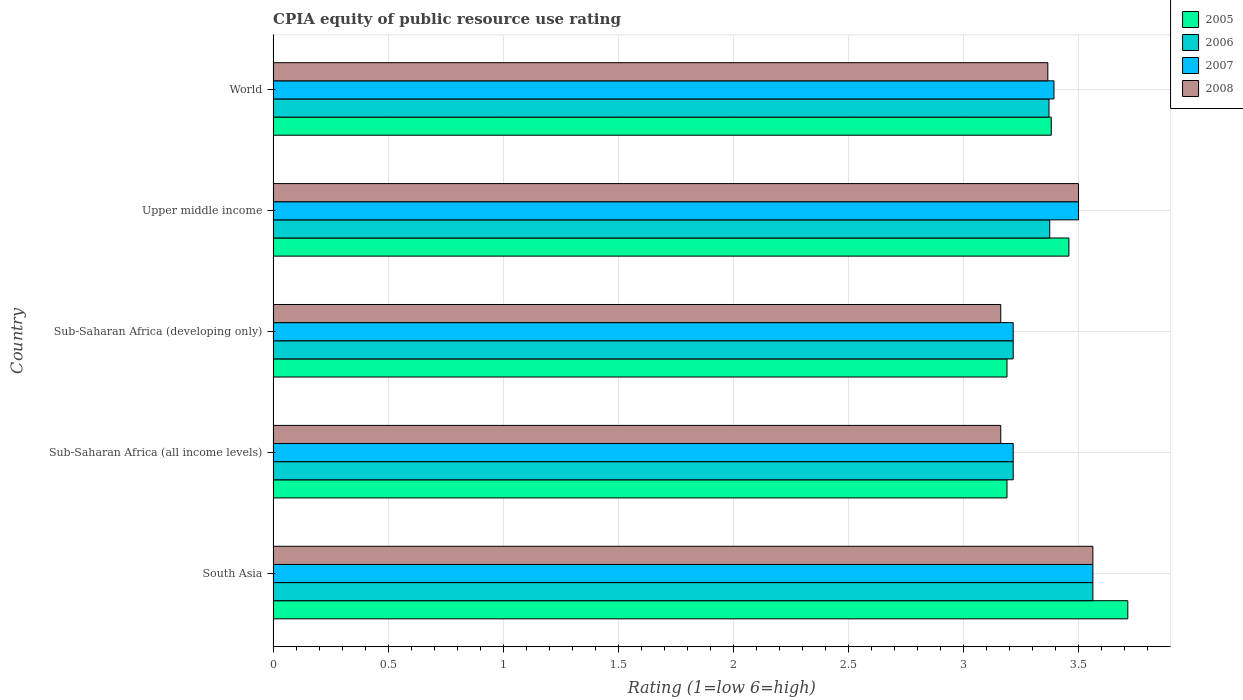How many different coloured bars are there?
Provide a succinct answer. 4. Are the number of bars per tick equal to the number of legend labels?
Keep it short and to the point. Yes. Are the number of bars on each tick of the Y-axis equal?
Make the answer very short. Yes. How many bars are there on the 1st tick from the top?
Offer a terse response. 4. What is the label of the 2nd group of bars from the top?
Make the answer very short. Upper middle income. In how many cases, is the number of bars for a given country not equal to the number of legend labels?
Provide a short and direct response. 0. What is the CPIA rating in 2005 in Upper middle income?
Keep it short and to the point. 3.46. Across all countries, what is the maximum CPIA rating in 2006?
Provide a short and direct response. 3.56. Across all countries, what is the minimum CPIA rating in 2005?
Keep it short and to the point. 3.19. In which country was the CPIA rating in 2006 maximum?
Your answer should be very brief. South Asia. In which country was the CPIA rating in 2007 minimum?
Provide a succinct answer. Sub-Saharan Africa (all income levels). What is the total CPIA rating in 2007 in the graph?
Offer a very short reply. 16.89. What is the difference between the CPIA rating in 2005 in South Asia and that in Sub-Saharan Africa (developing only)?
Your response must be concise. 0.53. What is the difference between the CPIA rating in 2008 in Sub-Saharan Africa (all income levels) and the CPIA rating in 2006 in Sub-Saharan Africa (developing only)?
Offer a terse response. -0.05. What is the average CPIA rating in 2006 per country?
Your answer should be compact. 3.35. What is the difference between the CPIA rating in 2005 and CPIA rating in 2006 in South Asia?
Offer a very short reply. 0.15. What is the ratio of the CPIA rating in 2006 in Sub-Saharan Africa (all income levels) to that in Upper middle income?
Offer a terse response. 0.95. Is the CPIA rating in 2008 in South Asia less than that in Sub-Saharan Africa (all income levels)?
Provide a succinct answer. No. What is the difference between the highest and the second highest CPIA rating in 2005?
Keep it short and to the point. 0.26. What is the difference between the highest and the lowest CPIA rating in 2005?
Your response must be concise. 0.53. In how many countries, is the CPIA rating in 2008 greater than the average CPIA rating in 2008 taken over all countries?
Your answer should be very brief. 3. Is it the case that in every country, the sum of the CPIA rating in 2005 and CPIA rating in 2007 is greater than the sum of CPIA rating in 2008 and CPIA rating in 2006?
Your response must be concise. No. Is it the case that in every country, the sum of the CPIA rating in 2006 and CPIA rating in 2008 is greater than the CPIA rating in 2005?
Your response must be concise. Yes. How many countries are there in the graph?
Give a very brief answer. 5. Does the graph contain grids?
Your answer should be compact. Yes. Where does the legend appear in the graph?
Provide a succinct answer. Top right. What is the title of the graph?
Offer a very short reply. CPIA equity of public resource use rating. What is the Rating (1=low 6=high) of 2005 in South Asia?
Your response must be concise. 3.71. What is the Rating (1=low 6=high) in 2006 in South Asia?
Your response must be concise. 3.56. What is the Rating (1=low 6=high) in 2007 in South Asia?
Give a very brief answer. 3.56. What is the Rating (1=low 6=high) in 2008 in South Asia?
Your response must be concise. 3.56. What is the Rating (1=low 6=high) of 2005 in Sub-Saharan Africa (all income levels)?
Ensure brevity in your answer.  3.19. What is the Rating (1=low 6=high) of 2006 in Sub-Saharan Africa (all income levels)?
Provide a short and direct response. 3.22. What is the Rating (1=low 6=high) of 2007 in Sub-Saharan Africa (all income levels)?
Your answer should be very brief. 3.22. What is the Rating (1=low 6=high) in 2008 in Sub-Saharan Africa (all income levels)?
Provide a short and direct response. 3.16. What is the Rating (1=low 6=high) in 2005 in Sub-Saharan Africa (developing only)?
Your answer should be very brief. 3.19. What is the Rating (1=low 6=high) in 2006 in Sub-Saharan Africa (developing only)?
Keep it short and to the point. 3.22. What is the Rating (1=low 6=high) in 2007 in Sub-Saharan Africa (developing only)?
Ensure brevity in your answer.  3.22. What is the Rating (1=low 6=high) of 2008 in Sub-Saharan Africa (developing only)?
Your answer should be very brief. 3.16. What is the Rating (1=low 6=high) of 2005 in Upper middle income?
Ensure brevity in your answer.  3.46. What is the Rating (1=low 6=high) of 2006 in Upper middle income?
Offer a very short reply. 3.38. What is the Rating (1=low 6=high) in 2007 in Upper middle income?
Your answer should be very brief. 3.5. What is the Rating (1=low 6=high) of 2008 in Upper middle income?
Your answer should be compact. 3.5. What is the Rating (1=low 6=high) in 2005 in World?
Offer a very short reply. 3.38. What is the Rating (1=low 6=high) in 2006 in World?
Give a very brief answer. 3.37. What is the Rating (1=low 6=high) in 2007 in World?
Keep it short and to the point. 3.39. What is the Rating (1=low 6=high) in 2008 in World?
Ensure brevity in your answer.  3.37. Across all countries, what is the maximum Rating (1=low 6=high) of 2005?
Make the answer very short. 3.71. Across all countries, what is the maximum Rating (1=low 6=high) of 2006?
Offer a very short reply. 3.56. Across all countries, what is the maximum Rating (1=low 6=high) of 2007?
Keep it short and to the point. 3.56. Across all countries, what is the maximum Rating (1=low 6=high) in 2008?
Provide a short and direct response. 3.56. Across all countries, what is the minimum Rating (1=low 6=high) of 2005?
Make the answer very short. 3.19. Across all countries, what is the minimum Rating (1=low 6=high) of 2006?
Provide a succinct answer. 3.22. Across all countries, what is the minimum Rating (1=low 6=high) in 2007?
Ensure brevity in your answer.  3.22. Across all countries, what is the minimum Rating (1=low 6=high) in 2008?
Make the answer very short. 3.16. What is the total Rating (1=low 6=high) of 2005 in the graph?
Your response must be concise. 16.93. What is the total Rating (1=low 6=high) of 2006 in the graph?
Keep it short and to the point. 16.74. What is the total Rating (1=low 6=high) in 2007 in the graph?
Provide a succinct answer. 16.89. What is the total Rating (1=low 6=high) in 2008 in the graph?
Provide a succinct answer. 16.75. What is the difference between the Rating (1=low 6=high) in 2005 in South Asia and that in Sub-Saharan Africa (all income levels)?
Offer a very short reply. 0.53. What is the difference between the Rating (1=low 6=high) in 2006 in South Asia and that in Sub-Saharan Africa (all income levels)?
Provide a succinct answer. 0.35. What is the difference between the Rating (1=low 6=high) in 2007 in South Asia and that in Sub-Saharan Africa (all income levels)?
Your answer should be compact. 0.35. What is the difference between the Rating (1=low 6=high) of 2008 in South Asia and that in Sub-Saharan Africa (all income levels)?
Provide a short and direct response. 0.4. What is the difference between the Rating (1=low 6=high) of 2005 in South Asia and that in Sub-Saharan Africa (developing only)?
Give a very brief answer. 0.53. What is the difference between the Rating (1=low 6=high) in 2006 in South Asia and that in Sub-Saharan Africa (developing only)?
Offer a very short reply. 0.35. What is the difference between the Rating (1=low 6=high) of 2007 in South Asia and that in Sub-Saharan Africa (developing only)?
Keep it short and to the point. 0.35. What is the difference between the Rating (1=low 6=high) of 2008 in South Asia and that in Sub-Saharan Africa (developing only)?
Provide a short and direct response. 0.4. What is the difference between the Rating (1=low 6=high) of 2005 in South Asia and that in Upper middle income?
Provide a succinct answer. 0.26. What is the difference between the Rating (1=low 6=high) of 2006 in South Asia and that in Upper middle income?
Keep it short and to the point. 0.19. What is the difference between the Rating (1=low 6=high) of 2007 in South Asia and that in Upper middle income?
Provide a succinct answer. 0.06. What is the difference between the Rating (1=low 6=high) in 2008 in South Asia and that in Upper middle income?
Give a very brief answer. 0.06. What is the difference between the Rating (1=low 6=high) in 2005 in South Asia and that in World?
Provide a succinct answer. 0.33. What is the difference between the Rating (1=low 6=high) of 2006 in South Asia and that in World?
Ensure brevity in your answer.  0.19. What is the difference between the Rating (1=low 6=high) of 2007 in South Asia and that in World?
Give a very brief answer. 0.17. What is the difference between the Rating (1=low 6=high) of 2008 in South Asia and that in World?
Your answer should be compact. 0.2. What is the difference between the Rating (1=low 6=high) in 2008 in Sub-Saharan Africa (all income levels) and that in Sub-Saharan Africa (developing only)?
Provide a succinct answer. 0. What is the difference between the Rating (1=low 6=high) of 2005 in Sub-Saharan Africa (all income levels) and that in Upper middle income?
Your answer should be very brief. -0.27. What is the difference between the Rating (1=low 6=high) in 2006 in Sub-Saharan Africa (all income levels) and that in Upper middle income?
Keep it short and to the point. -0.16. What is the difference between the Rating (1=low 6=high) of 2007 in Sub-Saharan Africa (all income levels) and that in Upper middle income?
Your answer should be very brief. -0.28. What is the difference between the Rating (1=low 6=high) of 2008 in Sub-Saharan Africa (all income levels) and that in Upper middle income?
Your answer should be compact. -0.34. What is the difference between the Rating (1=low 6=high) of 2005 in Sub-Saharan Africa (all income levels) and that in World?
Provide a short and direct response. -0.19. What is the difference between the Rating (1=low 6=high) in 2006 in Sub-Saharan Africa (all income levels) and that in World?
Offer a terse response. -0.16. What is the difference between the Rating (1=low 6=high) of 2007 in Sub-Saharan Africa (all income levels) and that in World?
Offer a terse response. -0.18. What is the difference between the Rating (1=low 6=high) in 2008 in Sub-Saharan Africa (all income levels) and that in World?
Your answer should be very brief. -0.2. What is the difference between the Rating (1=low 6=high) in 2005 in Sub-Saharan Africa (developing only) and that in Upper middle income?
Provide a succinct answer. -0.27. What is the difference between the Rating (1=low 6=high) in 2006 in Sub-Saharan Africa (developing only) and that in Upper middle income?
Offer a very short reply. -0.16. What is the difference between the Rating (1=low 6=high) of 2007 in Sub-Saharan Africa (developing only) and that in Upper middle income?
Provide a succinct answer. -0.28. What is the difference between the Rating (1=low 6=high) of 2008 in Sub-Saharan Africa (developing only) and that in Upper middle income?
Provide a short and direct response. -0.34. What is the difference between the Rating (1=low 6=high) in 2005 in Sub-Saharan Africa (developing only) and that in World?
Give a very brief answer. -0.19. What is the difference between the Rating (1=low 6=high) of 2006 in Sub-Saharan Africa (developing only) and that in World?
Make the answer very short. -0.16. What is the difference between the Rating (1=low 6=high) in 2007 in Sub-Saharan Africa (developing only) and that in World?
Offer a terse response. -0.18. What is the difference between the Rating (1=low 6=high) of 2008 in Sub-Saharan Africa (developing only) and that in World?
Offer a very short reply. -0.2. What is the difference between the Rating (1=low 6=high) of 2005 in Upper middle income and that in World?
Offer a very short reply. 0.08. What is the difference between the Rating (1=low 6=high) in 2006 in Upper middle income and that in World?
Offer a terse response. 0. What is the difference between the Rating (1=low 6=high) of 2007 in Upper middle income and that in World?
Provide a succinct answer. 0.11. What is the difference between the Rating (1=low 6=high) of 2008 in Upper middle income and that in World?
Your answer should be very brief. 0.13. What is the difference between the Rating (1=low 6=high) of 2005 in South Asia and the Rating (1=low 6=high) of 2006 in Sub-Saharan Africa (all income levels)?
Make the answer very short. 0.5. What is the difference between the Rating (1=low 6=high) in 2005 in South Asia and the Rating (1=low 6=high) in 2007 in Sub-Saharan Africa (all income levels)?
Your response must be concise. 0.5. What is the difference between the Rating (1=low 6=high) in 2005 in South Asia and the Rating (1=low 6=high) in 2008 in Sub-Saharan Africa (all income levels)?
Keep it short and to the point. 0.55. What is the difference between the Rating (1=low 6=high) of 2006 in South Asia and the Rating (1=low 6=high) of 2007 in Sub-Saharan Africa (all income levels)?
Give a very brief answer. 0.35. What is the difference between the Rating (1=low 6=high) of 2006 in South Asia and the Rating (1=low 6=high) of 2008 in Sub-Saharan Africa (all income levels)?
Provide a short and direct response. 0.4. What is the difference between the Rating (1=low 6=high) in 2007 in South Asia and the Rating (1=low 6=high) in 2008 in Sub-Saharan Africa (all income levels)?
Make the answer very short. 0.4. What is the difference between the Rating (1=low 6=high) of 2005 in South Asia and the Rating (1=low 6=high) of 2006 in Sub-Saharan Africa (developing only)?
Offer a terse response. 0.5. What is the difference between the Rating (1=low 6=high) of 2005 in South Asia and the Rating (1=low 6=high) of 2007 in Sub-Saharan Africa (developing only)?
Provide a succinct answer. 0.5. What is the difference between the Rating (1=low 6=high) of 2005 in South Asia and the Rating (1=low 6=high) of 2008 in Sub-Saharan Africa (developing only)?
Your response must be concise. 0.55. What is the difference between the Rating (1=low 6=high) in 2006 in South Asia and the Rating (1=low 6=high) in 2007 in Sub-Saharan Africa (developing only)?
Your response must be concise. 0.35. What is the difference between the Rating (1=low 6=high) in 2006 in South Asia and the Rating (1=low 6=high) in 2008 in Sub-Saharan Africa (developing only)?
Ensure brevity in your answer.  0.4. What is the difference between the Rating (1=low 6=high) in 2007 in South Asia and the Rating (1=low 6=high) in 2008 in Sub-Saharan Africa (developing only)?
Provide a succinct answer. 0.4. What is the difference between the Rating (1=low 6=high) in 2005 in South Asia and the Rating (1=low 6=high) in 2006 in Upper middle income?
Offer a terse response. 0.34. What is the difference between the Rating (1=low 6=high) in 2005 in South Asia and the Rating (1=low 6=high) in 2007 in Upper middle income?
Give a very brief answer. 0.21. What is the difference between the Rating (1=low 6=high) of 2005 in South Asia and the Rating (1=low 6=high) of 2008 in Upper middle income?
Your response must be concise. 0.21. What is the difference between the Rating (1=low 6=high) of 2006 in South Asia and the Rating (1=low 6=high) of 2007 in Upper middle income?
Keep it short and to the point. 0.06. What is the difference between the Rating (1=low 6=high) in 2006 in South Asia and the Rating (1=low 6=high) in 2008 in Upper middle income?
Offer a terse response. 0.06. What is the difference between the Rating (1=low 6=high) in 2007 in South Asia and the Rating (1=low 6=high) in 2008 in Upper middle income?
Your response must be concise. 0.06. What is the difference between the Rating (1=low 6=high) in 2005 in South Asia and the Rating (1=low 6=high) in 2006 in World?
Give a very brief answer. 0.34. What is the difference between the Rating (1=low 6=high) of 2005 in South Asia and the Rating (1=low 6=high) of 2007 in World?
Your response must be concise. 0.32. What is the difference between the Rating (1=low 6=high) of 2005 in South Asia and the Rating (1=low 6=high) of 2008 in World?
Ensure brevity in your answer.  0.35. What is the difference between the Rating (1=low 6=high) in 2006 in South Asia and the Rating (1=low 6=high) in 2007 in World?
Your answer should be compact. 0.17. What is the difference between the Rating (1=low 6=high) of 2006 in South Asia and the Rating (1=low 6=high) of 2008 in World?
Your answer should be very brief. 0.2. What is the difference between the Rating (1=low 6=high) in 2007 in South Asia and the Rating (1=low 6=high) in 2008 in World?
Keep it short and to the point. 0.2. What is the difference between the Rating (1=low 6=high) of 2005 in Sub-Saharan Africa (all income levels) and the Rating (1=low 6=high) of 2006 in Sub-Saharan Africa (developing only)?
Offer a very short reply. -0.03. What is the difference between the Rating (1=low 6=high) in 2005 in Sub-Saharan Africa (all income levels) and the Rating (1=low 6=high) in 2007 in Sub-Saharan Africa (developing only)?
Ensure brevity in your answer.  -0.03. What is the difference between the Rating (1=low 6=high) of 2005 in Sub-Saharan Africa (all income levels) and the Rating (1=low 6=high) of 2008 in Sub-Saharan Africa (developing only)?
Keep it short and to the point. 0.03. What is the difference between the Rating (1=low 6=high) in 2006 in Sub-Saharan Africa (all income levels) and the Rating (1=low 6=high) in 2007 in Sub-Saharan Africa (developing only)?
Offer a terse response. 0. What is the difference between the Rating (1=low 6=high) in 2006 in Sub-Saharan Africa (all income levels) and the Rating (1=low 6=high) in 2008 in Sub-Saharan Africa (developing only)?
Provide a short and direct response. 0.05. What is the difference between the Rating (1=low 6=high) in 2007 in Sub-Saharan Africa (all income levels) and the Rating (1=low 6=high) in 2008 in Sub-Saharan Africa (developing only)?
Offer a very short reply. 0.05. What is the difference between the Rating (1=low 6=high) of 2005 in Sub-Saharan Africa (all income levels) and the Rating (1=low 6=high) of 2006 in Upper middle income?
Your answer should be very brief. -0.19. What is the difference between the Rating (1=low 6=high) of 2005 in Sub-Saharan Africa (all income levels) and the Rating (1=low 6=high) of 2007 in Upper middle income?
Your response must be concise. -0.31. What is the difference between the Rating (1=low 6=high) of 2005 in Sub-Saharan Africa (all income levels) and the Rating (1=low 6=high) of 2008 in Upper middle income?
Ensure brevity in your answer.  -0.31. What is the difference between the Rating (1=low 6=high) in 2006 in Sub-Saharan Africa (all income levels) and the Rating (1=low 6=high) in 2007 in Upper middle income?
Offer a very short reply. -0.28. What is the difference between the Rating (1=low 6=high) in 2006 in Sub-Saharan Africa (all income levels) and the Rating (1=low 6=high) in 2008 in Upper middle income?
Keep it short and to the point. -0.28. What is the difference between the Rating (1=low 6=high) of 2007 in Sub-Saharan Africa (all income levels) and the Rating (1=low 6=high) of 2008 in Upper middle income?
Your response must be concise. -0.28. What is the difference between the Rating (1=low 6=high) of 2005 in Sub-Saharan Africa (all income levels) and the Rating (1=low 6=high) of 2006 in World?
Make the answer very short. -0.18. What is the difference between the Rating (1=low 6=high) in 2005 in Sub-Saharan Africa (all income levels) and the Rating (1=low 6=high) in 2007 in World?
Your answer should be compact. -0.2. What is the difference between the Rating (1=low 6=high) in 2005 in Sub-Saharan Africa (all income levels) and the Rating (1=low 6=high) in 2008 in World?
Provide a short and direct response. -0.18. What is the difference between the Rating (1=low 6=high) in 2006 in Sub-Saharan Africa (all income levels) and the Rating (1=low 6=high) in 2007 in World?
Offer a very short reply. -0.18. What is the difference between the Rating (1=low 6=high) in 2006 in Sub-Saharan Africa (all income levels) and the Rating (1=low 6=high) in 2008 in World?
Your answer should be very brief. -0.15. What is the difference between the Rating (1=low 6=high) of 2007 in Sub-Saharan Africa (all income levels) and the Rating (1=low 6=high) of 2008 in World?
Offer a very short reply. -0.15. What is the difference between the Rating (1=low 6=high) of 2005 in Sub-Saharan Africa (developing only) and the Rating (1=low 6=high) of 2006 in Upper middle income?
Ensure brevity in your answer.  -0.19. What is the difference between the Rating (1=low 6=high) of 2005 in Sub-Saharan Africa (developing only) and the Rating (1=low 6=high) of 2007 in Upper middle income?
Offer a terse response. -0.31. What is the difference between the Rating (1=low 6=high) in 2005 in Sub-Saharan Africa (developing only) and the Rating (1=low 6=high) in 2008 in Upper middle income?
Your answer should be very brief. -0.31. What is the difference between the Rating (1=low 6=high) in 2006 in Sub-Saharan Africa (developing only) and the Rating (1=low 6=high) in 2007 in Upper middle income?
Your answer should be compact. -0.28. What is the difference between the Rating (1=low 6=high) of 2006 in Sub-Saharan Africa (developing only) and the Rating (1=low 6=high) of 2008 in Upper middle income?
Provide a short and direct response. -0.28. What is the difference between the Rating (1=low 6=high) of 2007 in Sub-Saharan Africa (developing only) and the Rating (1=low 6=high) of 2008 in Upper middle income?
Provide a succinct answer. -0.28. What is the difference between the Rating (1=low 6=high) of 2005 in Sub-Saharan Africa (developing only) and the Rating (1=low 6=high) of 2006 in World?
Your answer should be very brief. -0.18. What is the difference between the Rating (1=low 6=high) in 2005 in Sub-Saharan Africa (developing only) and the Rating (1=low 6=high) in 2007 in World?
Give a very brief answer. -0.2. What is the difference between the Rating (1=low 6=high) in 2005 in Sub-Saharan Africa (developing only) and the Rating (1=low 6=high) in 2008 in World?
Your response must be concise. -0.18. What is the difference between the Rating (1=low 6=high) in 2006 in Sub-Saharan Africa (developing only) and the Rating (1=low 6=high) in 2007 in World?
Ensure brevity in your answer.  -0.18. What is the difference between the Rating (1=low 6=high) in 2006 in Sub-Saharan Africa (developing only) and the Rating (1=low 6=high) in 2008 in World?
Offer a terse response. -0.15. What is the difference between the Rating (1=low 6=high) of 2007 in Sub-Saharan Africa (developing only) and the Rating (1=low 6=high) of 2008 in World?
Provide a succinct answer. -0.15. What is the difference between the Rating (1=low 6=high) of 2005 in Upper middle income and the Rating (1=low 6=high) of 2006 in World?
Keep it short and to the point. 0.09. What is the difference between the Rating (1=low 6=high) in 2005 in Upper middle income and the Rating (1=low 6=high) in 2007 in World?
Your response must be concise. 0.07. What is the difference between the Rating (1=low 6=high) in 2005 in Upper middle income and the Rating (1=low 6=high) in 2008 in World?
Keep it short and to the point. 0.09. What is the difference between the Rating (1=low 6=high) in 2006 in Upper middle income and the Rating (1=low 6=high) in 2007 in World?
Provide a succinct answer. -0.02. What is the difference between the Rating (1=low 6=high) of 2006 in Upper middle income and the Rating (1=low 6=high) of 2008 in World?
Offer a terse response. 0.01. What is the difference between the Rating (1=low 6=high) in 2007 in Upper middle income and the Rating (1=low 6=high) in 2008 in World?
Ensure brevity in your answer.  0.13. What is the average Rating (1=low 6=high) in 2005 per country?
Your response must be concise. 3.39. What is the average Rating (1=low 6=high) of 2006 per country?
Make the answer very short. 3.35. What is the average Rating (1=low 6=high) in 2007 per country?
Provide a short and direct response. 3.38. What is the average Rating (1=low 6=high) of 2008 per country?
Provide a short and direct response. 3.35. What is the difference between the Rating (1=low 6=high) of 2005 and Rating (1=low 6=high) of 2006 in South Asia?
Your answer should be compact. 0.15. What is the difference between the Rating (1=low 6=high) of 2005 and Rating (1=low 6=high) of 2007 in South Asia?
Your answer should be compact. 0.15. What is the difference between the Rating (1=low 6=high) of 2005 and Rating (1=low 6=high) of 2008 in South Asia?
Your answer should be very brief. 0.15. What is the difference between the Rating (1=low 6=high) in 2006 and Rating (1=low 6=high) in 2007 in South Asia?
Provide a succinct answer. 0. What is the difference between the Rating (1=low 6=high) of 2006 and Rating (1=low 6=high) of 2008 in South Asia?
Make the answer very short. 0. What is the difference between the Rating (1=low 6=high) of 2007 and Rating (1=low 6=high) of 2008 in South Asia?
Keep it short and to the point. 0. What is the difference between the Rating (1=low 6=high) of 2005 and Rating (1=low 6=high) of 2006 in Sub-Saharan Africa (all income levels)?
Provide a succinct answer. -0.03. What is the difference between the Rating (1=low 6=high) in 2005 and Rating (1=low 6=high) in 2007 in Sub-Saharan Africa (all income levels)?
Your answer should be very brief. -0.03. What is the difference between the Rating (1=low 6=high) of 2005 and Rating (1=low 6=high) of 2008 in Sub-Saharan Africa (all income levels)?
Ensure brevity in your answer.  0.03. What is the difference between the Rating (1=low 6=high) of 2006 and Rating (1=low 6=high) of 2008 in Sub-Saharan Africa (all income levels)?
Provide a short and direct response. 0.05. What is the difference between the Rating (1=low 6=high) in 2007 and Rating (1=low 6=high) in 2008 in Sub-Saharan Africa (all income levels)?
Provide a succinct answer. 0.05. What is the difference between the Rating (1=low 6=high) in 2005 and Rating (1=low 6=high) in 2006 in Sub-Saharan Africa (developing only)?
Make the answer very short. -0.03. What is the difference between the Rating (1=low 6=high) of 2005 and Rating (1=low 6=high) of 2007 in Sub-Saharan Africa (developing only)?
Ensure brevity in your answer.  -0.03. What is the difference between the Rating (1=low 6=high) in 2005 and Rating (1=low 6=high) in 2008 in Sub-Saharan Africa (developing only)?
Your answer should be very brief. 0.03. What is the difference between the Rating (1=low 6=high) of 2006 and Rating (1=low 6=high) of 2008 in Sub-Saharan Africa (developing only)?
Your response must be concise. 0.05. What is the difference between the Rating (1=low 6=high) in 2007 and Rating (1=low 6=high) in 2008 in Sub-Saharan Africa (developing only)?
Offer a terse response. 0.05. What is the difference between the Rating (1=low 6=high) in 2005 and Rating (1=low 6=high) in 2006 in Upper middle income?
Provide a succinct answer. 0.08. What is the difference between the Rating (1=low 6=high) in 2005 and Rating (1=low 6=high) in 2007 in Upper middle income?
Offer a very short reply. -0.04. What is the difference between the Rating (1=low 6=high) of 2005 and Rating (1=low 6=high) of 2008 in Upper middle income?
Offer a very short reply. -0.04. What is the difference between the Rating (1=low 6=high) of 2006 and Rating (1=low 6=high) of 2007 in Upper middle income?
Make the answer very short. -0.12. What is the difference between the Rating (1=low 6=high) of 2006 and Rating (1=low 6=high) of 2008 in Upper middle income?
Give a very brief answer. -0.12. What is the difference between the Rating (1=low 6=high) in 2007 and Rating (1=low 6=high) in 2008 in Upper middle income?
Your response must be concise. 0. What is the difference between the Rating (1=low 6=high) of 2005 and Rating (1=low 6=high) of 2006 in World?
Keep it short and to the point. 0.01. What is the difference between the Rating (1=low 6=high) of 2005 and Rating (1=low 6=high) of 2007 in World?
Make the answer very short. -0.01. What is the difference between the Rating (1=low 6=high) in 2005 and Rating (1=low 6=high) in 2008 in World?
Your answer should be very brief. 0.01. What is the difference between the Rating (1=low 6=high) of 2006 and Rating (1=low 6=high) of 2007 in World?
Provide a short and direct response. -0.02. What is the difference between the Rating (1=low 6=high) of 2006 and Rating (1=low 6=high) of 2008 in World?
Your answer should be compact. 0.01. What is the difference between the Rating (1=low 6=high) of 2007 and Rating (1=low 6=high) of 2008 in World?
Ensure brevity in your answer.  0.03. What is the ratio of the Rating (1=low 6=high) of 2005 in South Asia to that in Sub-Saharan Africa (all income levels)?
Your answer should be compact. 1.16. What is the ratio of the Rating (1=low 6=high) in 2006 in South Asia to that in Sub-Saharan Africa (all income levels)?
Your answer should be very brief. 1.11. What is the ratio of the Rating (1=low 6=high) of 2007 in South Asia to that in Sub-Saharan Africa (all income levels)?
Ensure brevity in your answer.  1.11. What is the ratio of the Rating (1=low 6=high) in 2008 in South Asia to that in Sub-Saharan Africa (all income levels)?
Offer a terse response. 1.13. What is the ratio of the Rating (1=low 6=high) in 2005 in South Asia to that in Sub-Saharan Africa (developing only)?
Offer a terse response. 1.16. What is the ratio of the Rating (1=low 6=high) of 2006 in South Asia to that in Sub-Saharan Africa (developing only)?
Your response must be concise. 1.11. What is the ratio of the Rating (1=low 6=high) in 2007 in South Asia to that in Sub-Saharan Africa (developing only)?
Provide a succinct answer. 1.11. What is the ratio of the Rating (1=low 6=high) in 2008 in South Asia to that in Sub-Saharan Africa (developing only)?
Provide a succinct answer. 1.13. What is the ratio of the Rating (1=low 6=high) in 2005 in South Asia to that in Upper middle income?
Provide a short and direct response. 1.07. What is the ratio of the Rating (1=low 6=high) of 2006 in South Asia to that in Upper middle income?
Your response must be concise. 1.06. What is the ratio of the Rating (1=low 6=high) of 2007 in South Asia to that in Upper middle income?
Offer a very short reply. 1.02. What is the ratio of the Rating (1=low 6=high) of 2008 in South Asia to that in Upper middle income?
Keep it short and to the point. 1.02. What is the ratio of the Rating (1=low 6=high) of 2005 in South Asia to that in World?
Give a very brief answer. 1.1. What is the ratio of the Rating (1=low 6=high) in 2006 in South Asia to that in World?
Provide a short and direct response. 1.06. What is the ratio of the Rating (1=low 6=high) in 2007 in South Asia to that in World?
Your answer should be compact. 1.05. What is the ratio of the Rating (1=low 6=high) in 2008 in South Asia to that in World?
Keep it short and to the point. 1.06. What is the ratio of the Rating (1=low 6=high) of 2005 in Sub-Saharan Africa (all income levels) to that in Sub-Saharan Africa (developing only)?
Make the answer very short. 1. What is the ratio of the Rating (1=low 6=high) of 2007 in Sub-Saharan Africa (all income levels) to that in Sub-Saharan Africa (developing only)?
Make the answer very short. 1. What is the ratio of the Rating (1=low 6=high) in 2008 in Sub-Saharan Africa (all income levels) to that in Sub-Saharan Africa (developing only)?
Your answer should be very brief. 1. What is the ratio of the Rating (1=low 6=high) of 2005 in Sub-Saharan Africa (all income levels) to that in Upper middle income?
Keep it short and to the point. 0.92. What is the ratio of the Rating (1=low 6=high) of 2006 in Sub-Saharan Africa (all income levels) to that in Upper middle income?
Your answer should be very brief. 0.95. What is the ratio of the Rating (1=low 6=high) in 2007 in Sub-Saharan Africa (all income levels) to that in Upper middle income?
Your response must be concise. 0.92. What is the ratio of the Rating (1=low 6=high) in 2008 in Sub-Saharan Africa (all income levels) to that in Upper middle income?
Offer a very short reply. 0.9. What is the ratio of the Rating (1=low 6=high) of 2005 in Sub-Saharan Africa (all income levels) to that in World?
Make the answer very short. 0.94. What is the ratio of the Rating (1=low 6=high) of 2006 in Sub-Saharan Africa (all income levels) to that in World?
Provide a succinct answer. 0.95. What is the ratio of the Rating (1=low 6=high) in 2007 in Sub-Saharan Africa (all income levels) to that in World?
Keep it short and to the point. 0.95. What is the ratio of the Rating (1=low 6=high) of 2008 in Sub-Saharan Africa (all income levels) to that in World?
Your answer should be compact. 0.94. What is the ratio of the Rating (1=low 6=high) in 2005 in Sub-Saharan Africa (developing only) to that in Upper middle income?
Provide a short and direct response. 0.92. What is the ratio of the Rating (1=low 6=high) in 2006 in Sub-Saharan Africa (developing only) to that in Upper middle income?
Offer a terse response. 0.95. What is the ratio of the Rating (1=low 6=high) in 2007 in Sub-Saharan Africa (developing only) to that in Upper middle income?
Make the answer very short. 0.92. What is the ratio of the Rating (1=low 6=high) in 2008 in Sub-Saharan Africa (developing only) to that in Upper middle income?
Make the answer very short. 0.9. What is the ratio of the Rating (1=low 6=high) in 2005 in Sub-Saharan Africa (developing only) to that in World?
Offer a very short reply. 0.94. What is the ratio of the Rating (1=low 6=high) in 2006 in Sub-Saharan Africa (developing only) to that in World?
Your response must be concise. 0.95. What is the ratio of the Rating (1=low 6=high) of 2007 in Sub-Saharan Africa (developing only) to that in World?
Ensure brevity in your answer.  0.95. What is the ratio of the Rating (1=low 6=high) of 2008 in Sub-Saharan Africa (developing only) to that in World?
Your answer should be compact. 0.94. What is the ratio of the Rating (1=low 6=high) in 2005 in Upper middle income to that in World?
Your answer should be compact. 1.02. What is the ratio of the Rating (1=low 6=high) in 2007 in Upper middle income to that in World?
Your answer should be very brief. 1.03. What is the ratio of the Rating (1=low 6=high) in 2008 in Upper middle income to that in World?
Your answer should be very brief. 1.04. What is the difference between the highest and the second highest Rating (1=low 6=high) in 2005?
Provide a short and direct response. 0.26. What is the difference between the highest and the second highest Rating (1=low 6=high) in 2006?
Offer a very short reply. 0.19. What is the difference between the highest and the second highest Rating (1=low 6=high) of 2007?
Keep it short and to the point. 0.06. What is the difference between the highest and the second highest Rating (1=low 6=high) in 2008?
Provide a succinct answer. 0.06. What is the difference between the highest and the lowest Rating (1=low 6=high) of 2005?
Offer a very short reply. 0.53. What is the difference between the highest and the lowest Rating (1=low 6=high) in 2006?
Provide a succinct answer. 0.35. What is the difference between the highest and the lowest Rating (1=low 6=high) of 2007?
Give a very brief answer. 0.35. What is the difference between the highest and the lowest Rating (1=low 6=high) in 2008?
Ensure brevity in your answer.  0.4. 